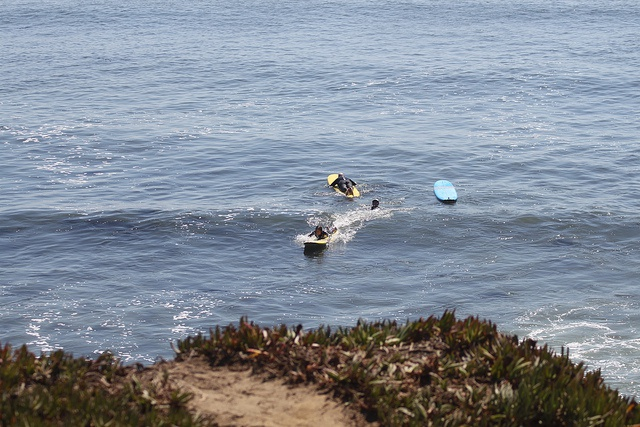Describe the objects in this image and their specific colors. I can see people in darkgray, black, gray, and maroon tones, surfboard in darkgray, lightblue, and black tones, people in darkgray, black, gray, and maroon tones, surfboard in darkgray, khaki, gray, and lightyellow tones, and surfboard in darkgray, lightgray, black, and khaki tones in this image. 